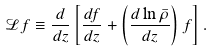<formula> <loc_0><loc_0><loc_500><loc_500>\mathcal { L } f \equiv \frac { d } { d z } \left [ \frac { d f } { d z } + \left ( \frac { d \ln \bar { \rho } } { d z } \right ) f \right ] .</formula> 